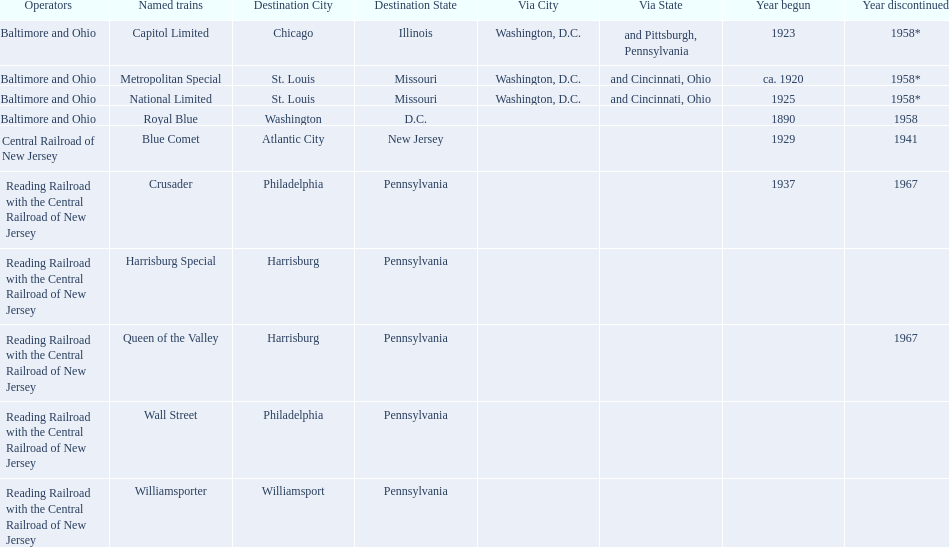How many trains were discontinued in 1958? 4. 